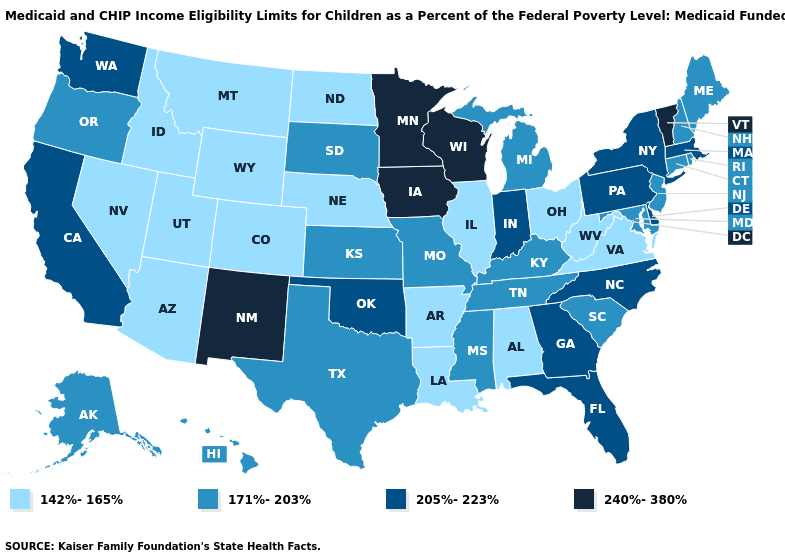Does the map have missing data?
Be succinct. No. What is the highest value in states that border Nebraska?
Short answer required. 240%-380%. What is the value of Texas?
Concise answer only. 171%-203%. Name the states that have a value in the range 205%-223%?
Give a very brief answer. California, Delaware, Florida, Georgia, Indiana, Massachusetts, New York, North Carolina, Oklahoma, Pennsylvania, Washington. What is the value of Maine?
Give a very brief answer. 171%-203%. Among the states that border Idaho , does Washington have the lowest value?
Quick response, please. No. Among the states that border Vermont , does Massachusetts have the lowest value?
Short answer required. No. What is the highest value in states that border New Jersey?
Write a very short answer. 205%-223%. What is the value of Michigan?
Be succinct. 171%-203%. Name the states that have a value in the range 240%-380%?
Quick response, please. Iowa, Minnesota, New Mexico, Vermont, Wisconsin. Name the states that have a value in the range 142%-165%?
Give a very brief answer. Alabama, Arizona, Arkansas, Colorado, Idaho, Illinois, Louisiana, Montana, Nebraska, Nevada, North Dakota, Ohio, Utah, Virginia, West Virginia, Wyoming. Does Indiana have a lower value than Wyoming?
Keep it brief. No. Name the states that have a value in the range 142%-165%?
Short answer required. Alabama, Arizona, Arkansas, Colorado, Idaho, Illinois, Louisiana, Montana, Nebraska, Nevada, North Dakota, Ohio, Utah, Virginia, West Virginia, Wyoming. What is the value of New York?
Keep it brief. 205%-223%. What is the highest value in the USA?
Answer briefly. 240%-380%. 